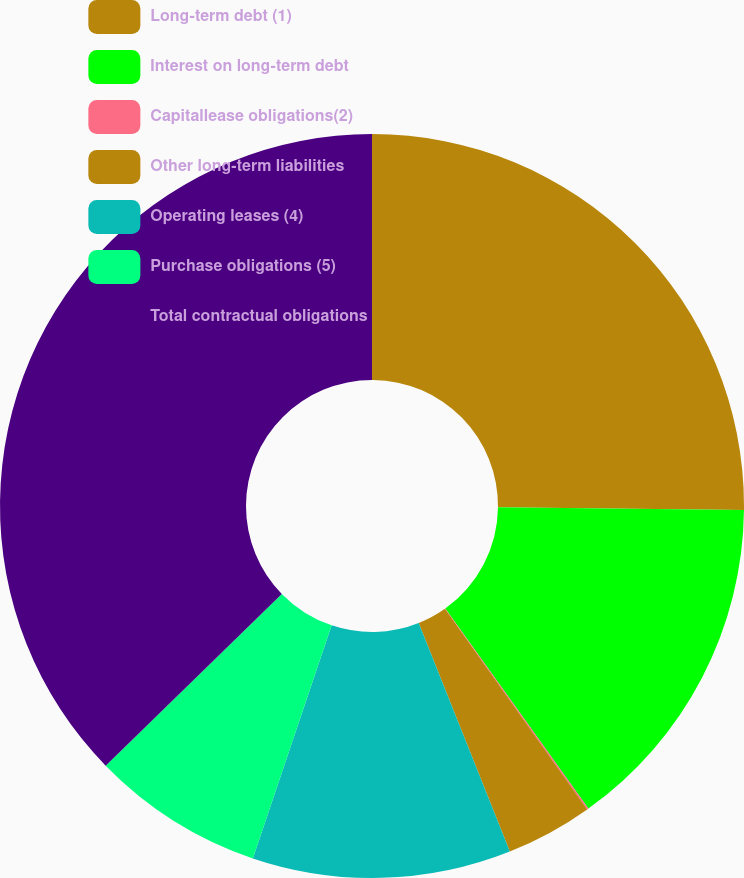Convert chart. <chart><loc_0><loc_0><loc_500><loc_500><pie_chart><fcel>Long-term debt (1)<fcel>Interest on long-term debt<fcel>Capitallease obligations(2)<fcel>Other long-term liabilities<fcel>Operating leases (4)<fcel>Purchase obligations (5)<fcel>Total contractual obligations<nl><fcel>25.17%<fcel>14.95%<fcel>0.06%<fcel>3.78%<fcel>11.23%<fcel>7.51%<fcel>37.3%<nl></chart> 